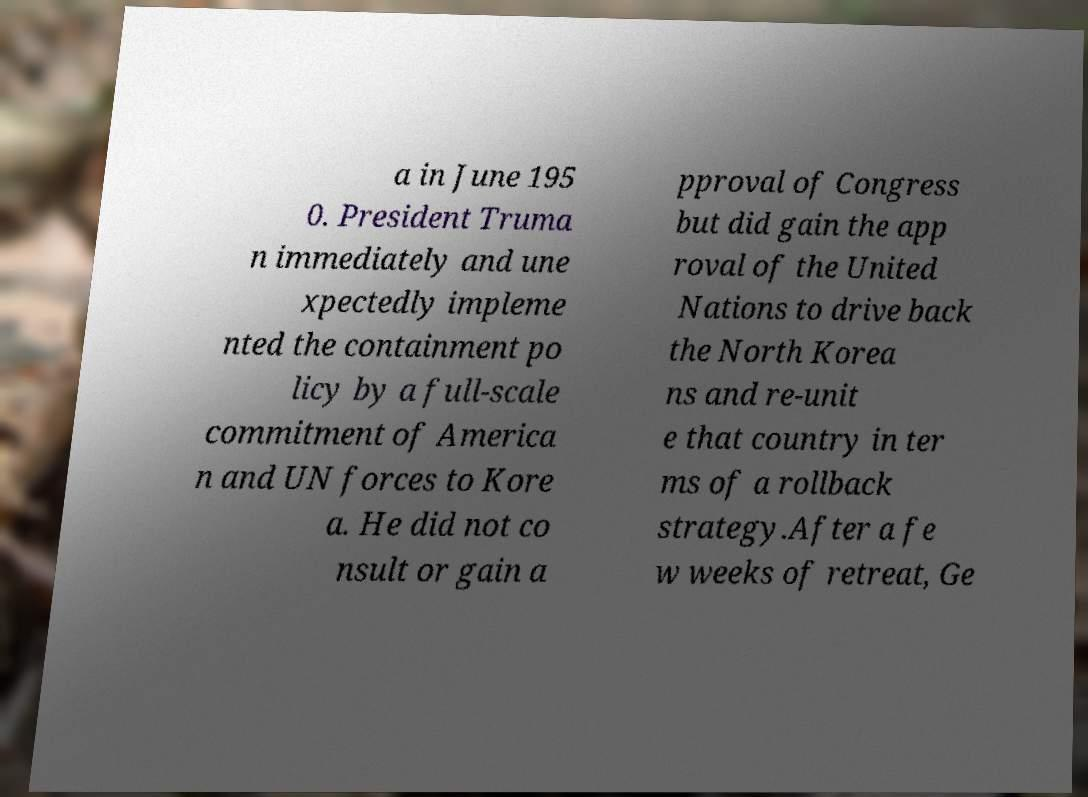Please read and relay the text visible in this image. What does it say? a in June 195 0. President Truma n immediately and une xpectedly impleme nted the containment po licy by a full-scale commitment of America n and UN forces to Kore a. He did not co nsult or gain a pproval of Congress but did gain the app roval of the United Nations to drive back the North Korea ns and re-unit e that country in ter ms of a rollback strategy.After a fe w weeks of retreat, Ge 